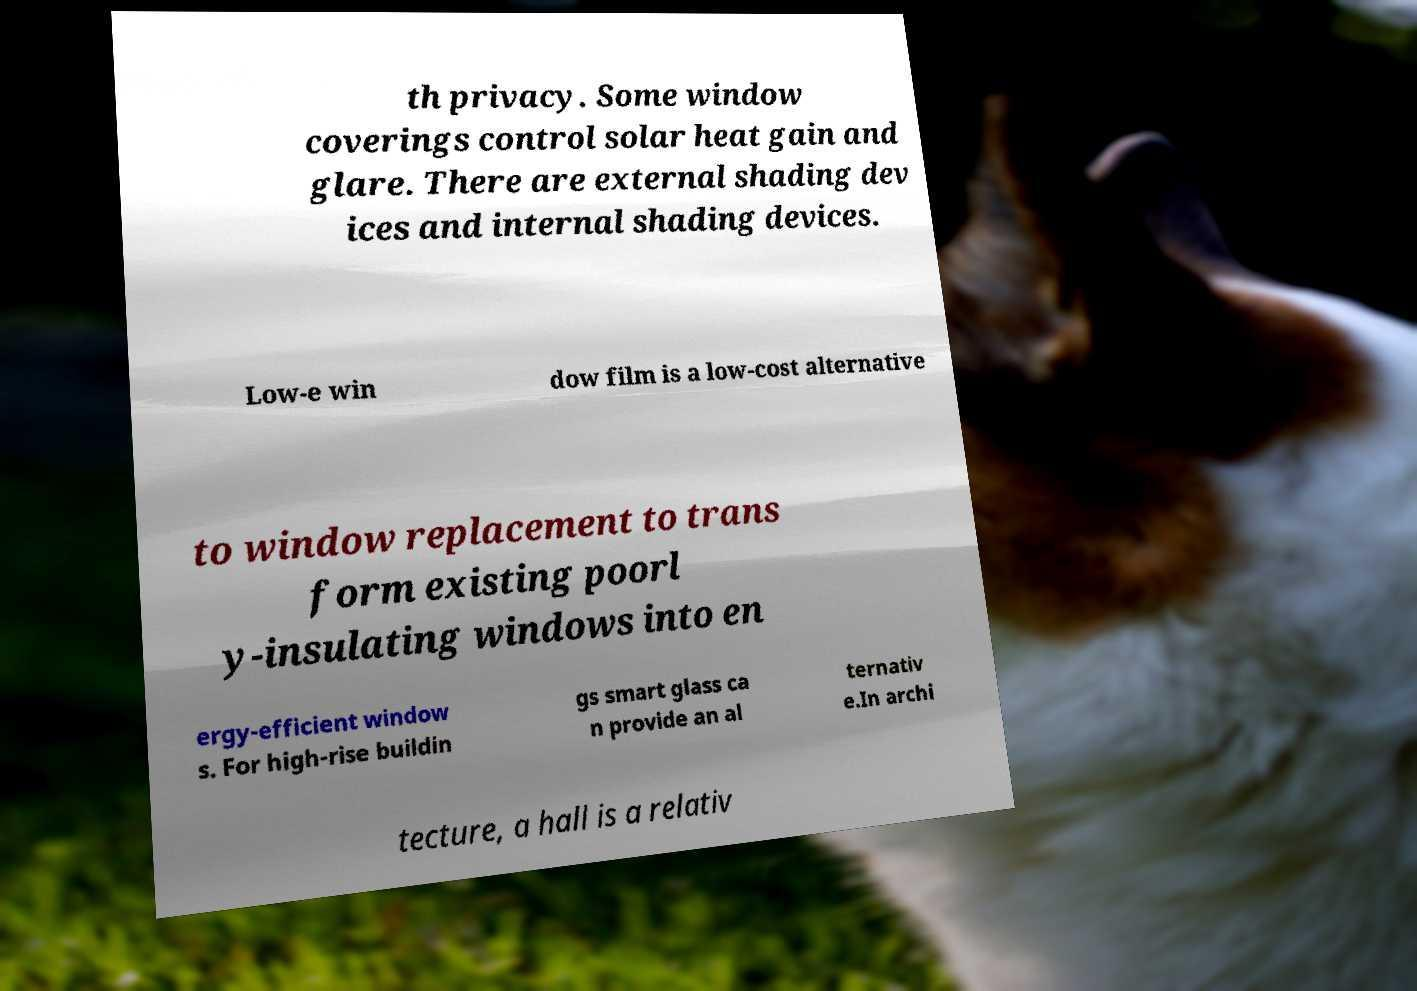Could you extract and type out the text from this image? th privacy. Some window coverings control solar heat gain and glare. There are external shading dev ices and internal shading devices. Low-e win dow film is a low-cost alternative to window replacement to trans form existing poorl y-insulating windows into en ergy-efficient window s. For high-rise buildin gs smart glass ca n provide an al ternativ e.In archi tecture, a hall is a relativ 